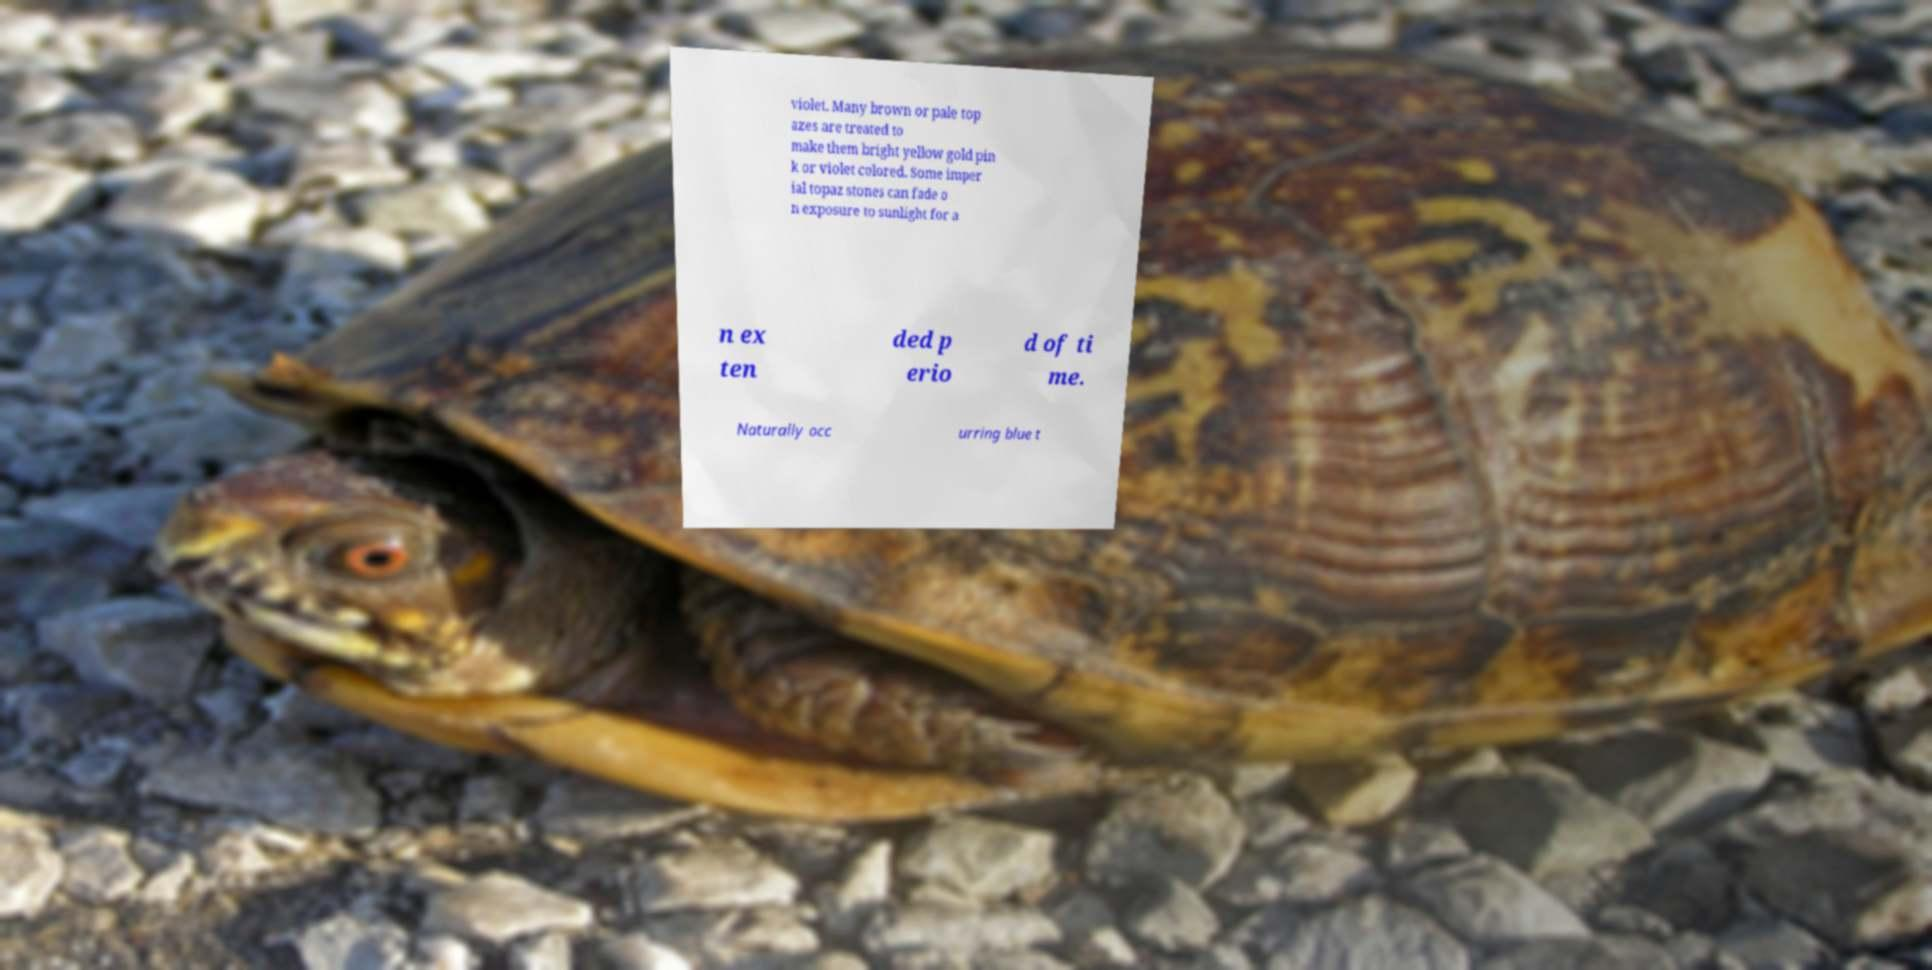Could you extract and type out the text from this image? violet. Many brown or pale top azes are treated to make them bright yellow gold pin k or violet colored. Some imper ial topaz stones can fade o n exposure to sunlight for a n ex ten ded p erio d of ti me. Naturally occ urring blue t 